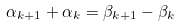<formula> <loc_0><loc_0><loc_500><loc_500>\alpha _ { k + 1 } + \alpha _ { k } = \beta _ { k + 1 } - \beta _ { k }</formula> 